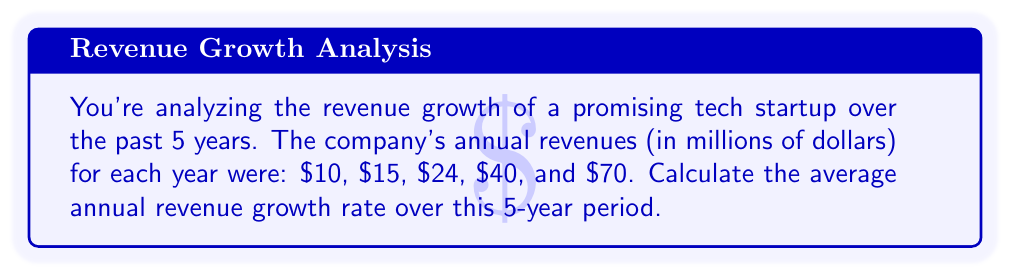Show me your answer to this math problem. To calculate the average annual revenue growth rate, we'll use the compound annual growth rate (CAGR) formula:

$$ CAGR = \left(\frac{\text{Ending Value}}{\text{Beginning Value}}\right)^{\frac{1}{\text{Number of Years}}} - 1 $$

Step 1: Identify the values
- Beginning Value: $10 million
- Ending Value: $70 million
- Number of Years: 5

Step 2: Plug the values into the CAGR formula

$$ CAGR = \left(\frac{70}{10}\right)^{\frac{1}{5}} - 1 $$

Step 3: Simplify the fraction inside the parentheses

$$ CAGR = (7)^{\frac{1}{5}} - 1 $$

Step 4: Calculate the fifth root of 7
$$ CAGR = 1.4758 - 1 $$

Step 5: Subtract 1 and convert to a percentage
$$ CAGR = 0.4758 = 47.58\% $$

Therefore, the average annual revenue growth rate over the 5-year period is approximately 47.58%.
Answer: 47.58% 